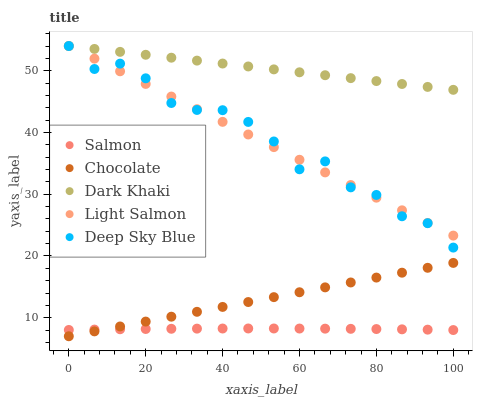Does Salmon have the minimum area under the curve?
Answer yes or no. Yes. Does Dark Khaki have the maximum area under the curve?
Answer yes or no. Yes. Does Light Salmon have the minimum area under the curve?
Answer yes or no. No. Does Light Salmon have the maximum area under the curve?
Answer yes or no. No. Is Dark Khaki the smoothest?
Answer yes or no. Yes. Is Deep Sky Blue the roughest?
Answer yes or no. Yes. Is Light Salmon the smoothest?
Answer yes or no. No. Is Light Salmon the roughest?
Answer yes or no. No. Does Chocolate have the lowest value?
Answer yes or no. Yes. Does Light Salmon have the lowest value?
Answer yes or no. No. Does Deep Sky Blue have the highest value?
Answer yes or no. Yes. Does Salmon have the highest value?
Answer yes or no. No. Is Salmon less than Deep Sky Blue?
Answer yes or no. Yes. Is Deep Sky Blue greater than Salmon?
Answer yes or no. Yes. Does Light Salmon intersect Dark Khaki?
Answer yes or no. Yes. Is Light Salmon less than Dark Khaki?
Answer yes or no. No. Is Light Salmon greater than Dark Khaki?
Answer yes or no. No. Does Salmon intersect Deep Sky Blue?
Answer yes or no. No. 